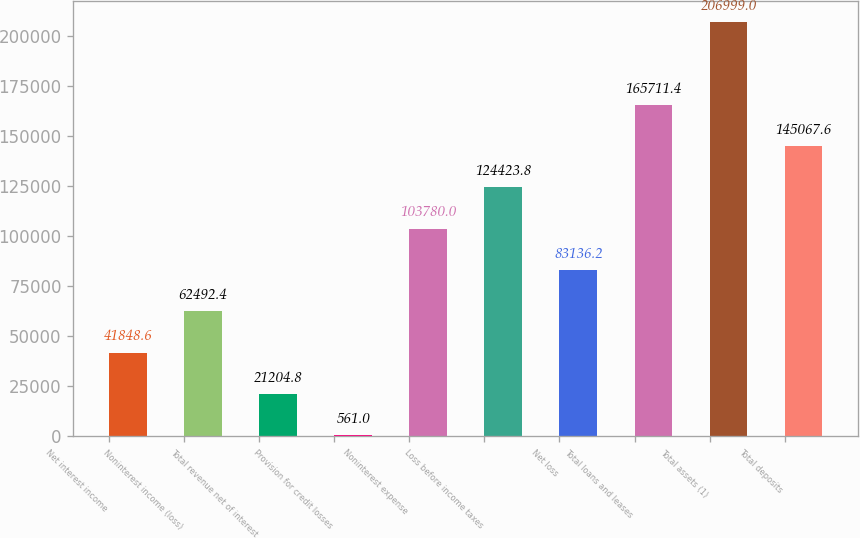<chart> <loc_0><loc_0><loc_500><loc_500><bar_chart><fcel>Net interest income<fcel>Noninterest income (loss)<fcel>Total revenue net of interest<fcel>Provision for credit losses<fcel>Noninterest expense<fcel>Loss before income taxes<fcel>Net loss<fcel>Total loans and leases<fcel>Total assets (1)<fcel>Total deposits<nl><fcel>41848.6<fcel>62492.4<fcel>21204.8<fcel>561<fcel>103780<fcel>124424<fcel>83136.2<fcel>165711<fcel>206999<fcel>145068<nl></chart> 